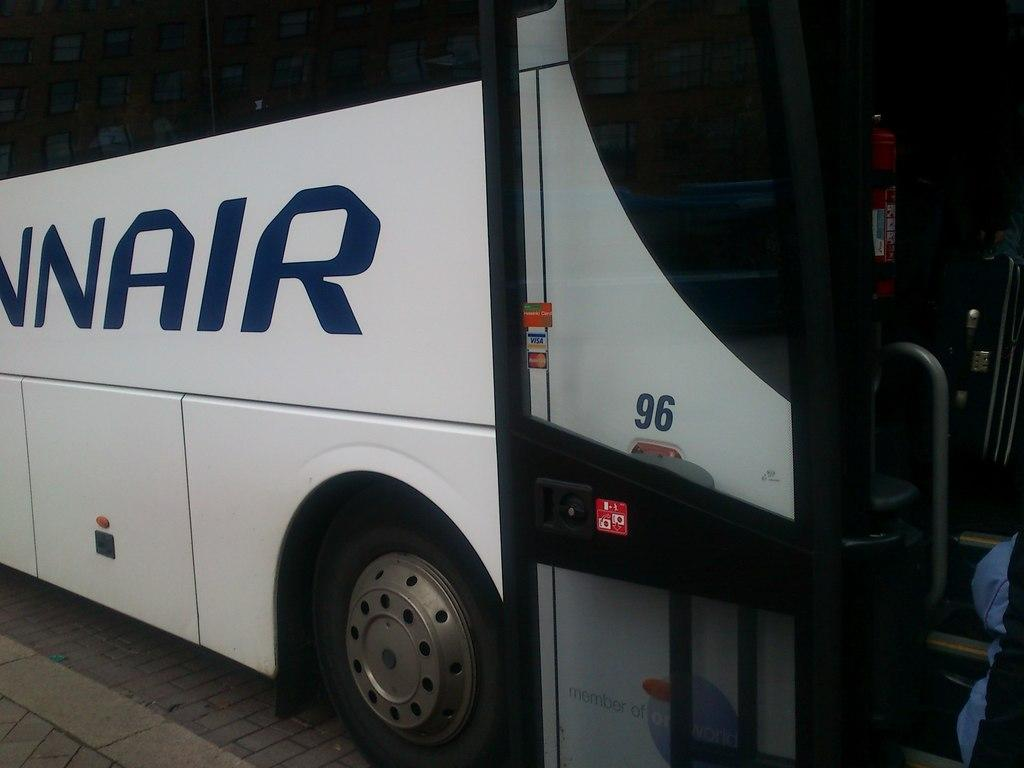What type of vehicle is in the image? There is a white color bus in the image. Where is the bus located? The bus is parked on the road. Can you describe anything or anyone near the bus? There is a person to the right of the bus. What can be seen in the background of the image? There is a road visible in the image. What type of quill is being used to write on the bus in the image? There is no quill present in the image, and the bus is parked, not being written on. 